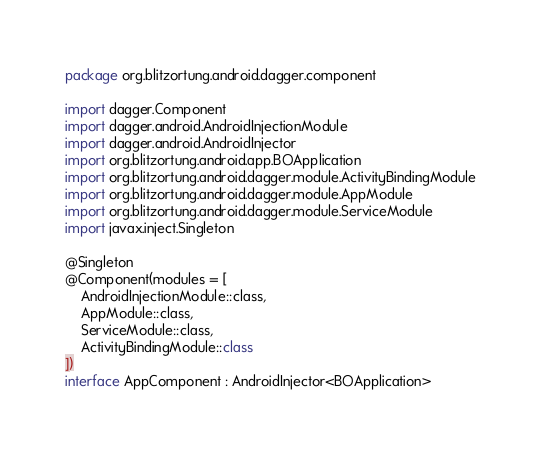Convert code to text. <code><loc_0><loc_0><loc_500><loc_500><_Kotlin_>package org.blitzortung.android.dagger.component

import dagger.Component
import dagger.android.AndroidInjectionModule
import dagger.android.AndroidInjector
import org.blitzortung.android.app.BOApplication
import org.blitzortung.android.dagger.module.ActivityBindingModule
import org.blitzortung.android.dagger.module.AppModule
import org.blitzortung.android.dagger.module.ServiceModule
import javax.inject.Singleton

@Singleton
@Component(modules = [
    AndroidInjectionModule::class,
    AppModule::class,
    ServiceModule::class,
    ActivityBindingModule::class
])
interface AppComponent : AndroidInjector<BOApplication>

</code> 